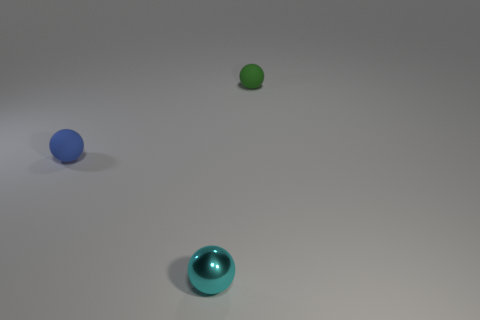Subtract all blue spheres. How many spheres are left? 2 Add 2 blue things. How many objects exist? 5 Subtract all blue spheres. How many spheres are left? 2 Add 1 tiny green matte things. How many tiny green matte things are left? 2 Add 2 small blue spheres. How many small blue spheres exist? 3 Subtract 1 green spheres. How many objects are left? 2 Subtract all yellow spheres. Subtract all yellow blocks. How many spheres are left? 3 Subtract all blue cylinders. How many blue balls are left? 1 Subtract all tiny green balls. Subtract all tiny green matte balls. How many objects are left? 1 